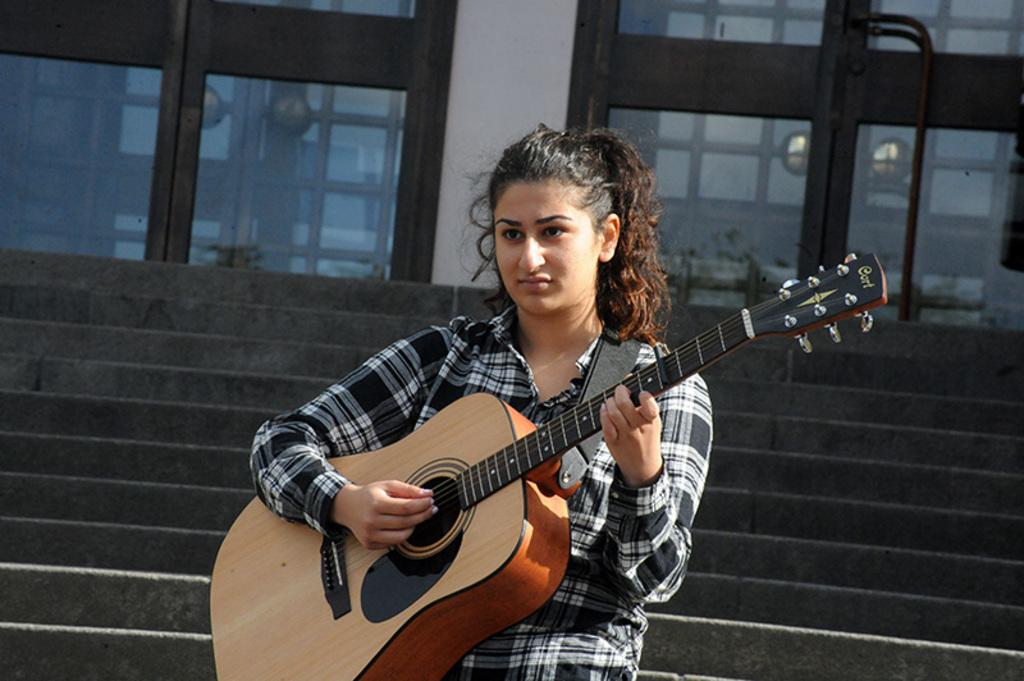Who is the main subject in the image? There is a woman in the image. Where is the woman positioned in the image? The woman is standing in the center of the image. What is the woman holding in her hand? The woman is holding a guitar in her hand. What architectural features can be seen in the background of the image? There are steps, doors, and a wall in the background of the image. What type of paste is being used to create the noise in the image? There is no paste or noise present in the image; it features a woman holding a guitar in the center of the image. 